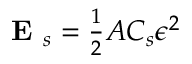<formula> <loc_0><loc_0><loc_500><loc_500>\begin{array} { r } { E _ { s } = \frac { 1 } { 2 } A C _ { s } \epsilon ^ { 2 } } \end{array}</formula> 